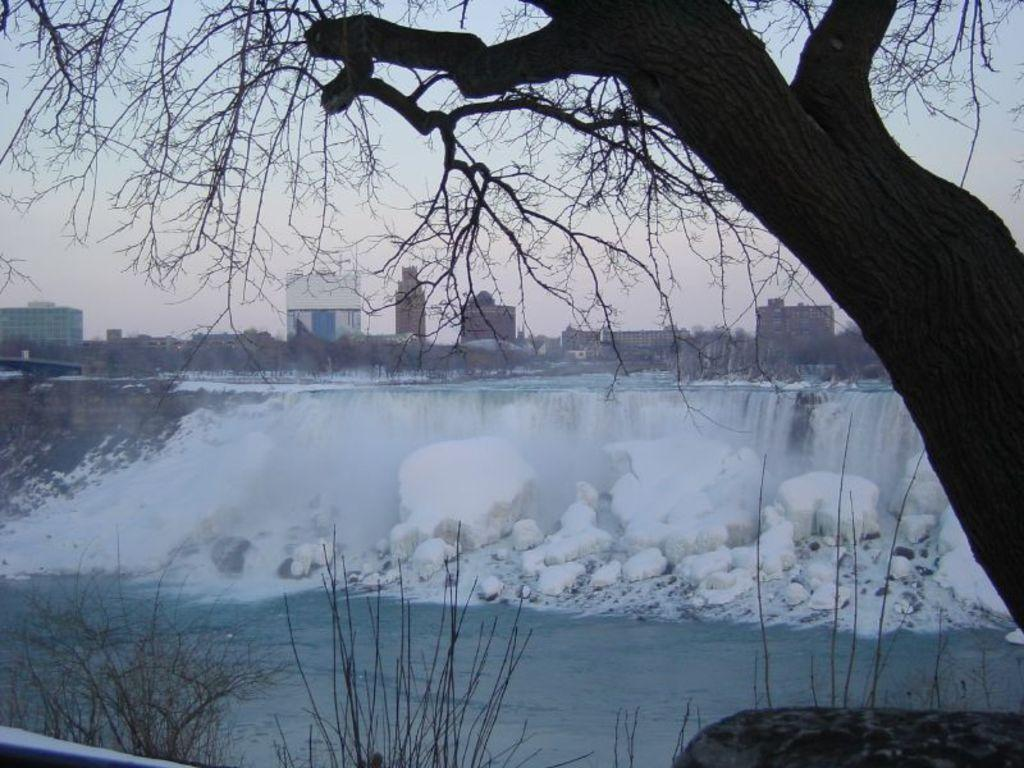What is the primary element visible in the image? There is water in the image. What type of natural object can be seen in the image? There is a tree in the image. What other types of vegetation are present in the image? There are plants in the image. What can be seen in the background of the image? There are buildings and the sky visible in the background of the image. What type of fruit is hanging from the tree in the image? There is no fruit visible on the tree in the image. Is there any beef being prepared in the image? There is no beef or any indication of food preparation in the image. 